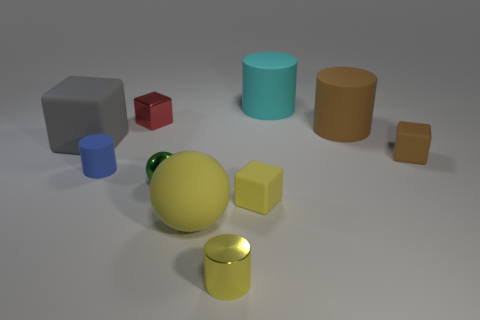How many other things are there of the same size as the red thing?
Your answer should be very brief. 5. The metal cylinder is what color?
Your answer should be compact. Yellow. There is a cylinder in front of the green object; what is it made of?
Provide a succinct answer. Metal. Are there an equal number of small rubber things left of the big gray matte block and large cyan rubber cylinders?
Provide a succinct answer. No. Do the yellow metal object and the small red object have the same shape?
Offer a very short reply. No. Are there any other things that have the same color as the matte ball?
Provide a short and direct response. Yes. The large rubber object that is both in front of the cyan object and on the right side of the tiny yellow matte thing has what shape?
Provide a short and direct response. Cylinder. Is the number of blue cylinders that are left of the big brown rubber thing the same as the number of small blocks in front of the big yellow sphere?
Make the answer very short. No. How many cubes are green metallic things or blue rubber things?
Ensure brevity in your answer.  0. What number of green balls are the same material as the red cube?
Your answer should be very brief. 1. 